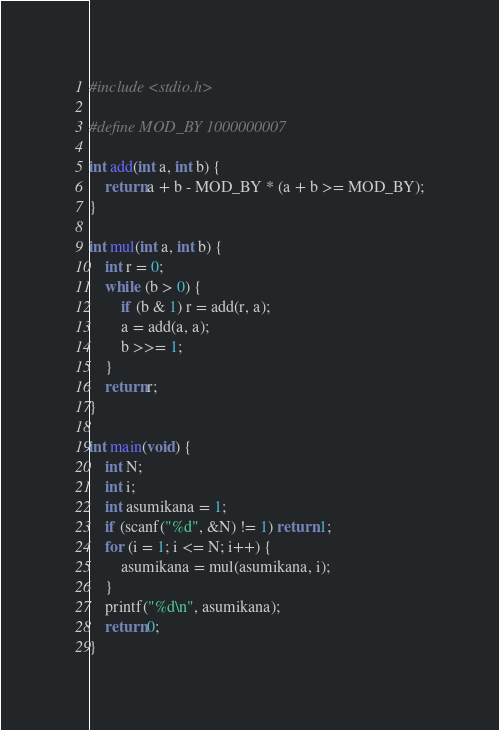Convert code to text. <code><loc_0><loc_0><loc_500><loc_500><_C_>#include <stdio.h>

#define MOD_BY 1000000007

int add(int a, int b) {
	return a + b - MOD_BY * (a + b >= MOD_BY);
}

int mul(int a, int b) {
	int r = 0;
	while (b > 0) {
		if (b & 1) r = add(r, a);
		a = add(a, a);
		b >>= 1;
	}
	return r;
}

int main(void) {
	int N;
	int i;
	int asumikana = 1;
	if (scanf("%d", &N) != 1) return 1;
	for (i = 1; i <= N; i++) {
		asumikana = mul(asumikana, i);
	}
	printf("%d\n", asumikana);
	return 0;
}
</code> 